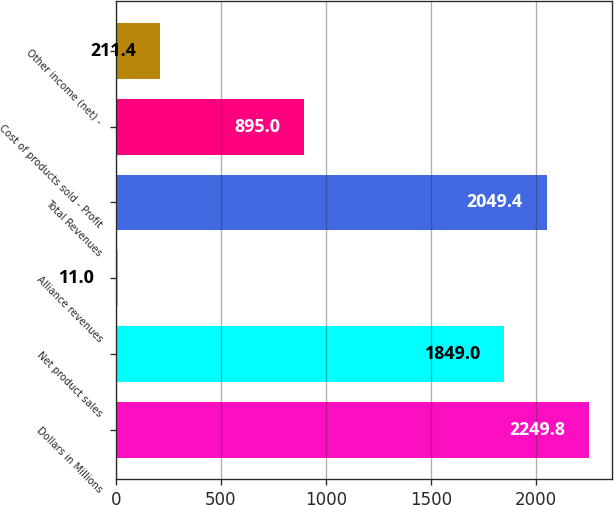Convert chart. <chart><loc_0><loc_0><loc_500><loc_500><bar_chart><fcel>Dollars in Millions<fcel>Net product sales<fcel>Alliance revenues<fcel>Total Revenues<fcel>Cost of products sold - Profit<fcel>Other income (net) -<nl><fcel>2249.8<fcel>1849<fcel>11<fcel>2049.4<fcel>895<fcel>211.4<nl></chart> 